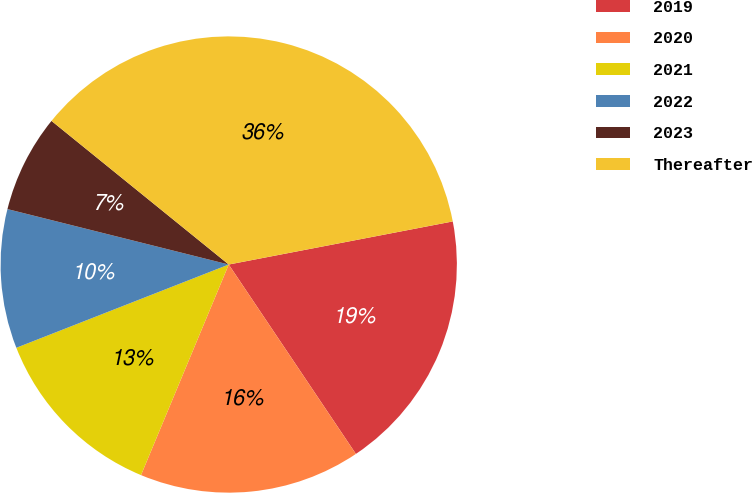Convert chart to OTSL. <chart><loc_0><loc_0><loc_500><loc_500><pie_chart><fcel>2019<fcel>2020<fcel>2021<fcel>2022<fcel>2023<fcel>Thereafter<nl><fcel>18.61%<fcel>15.69%<fcel>12.77%<fcel>9.85%<fcel>6.93%<fcel>36.13%<nl></chart> 